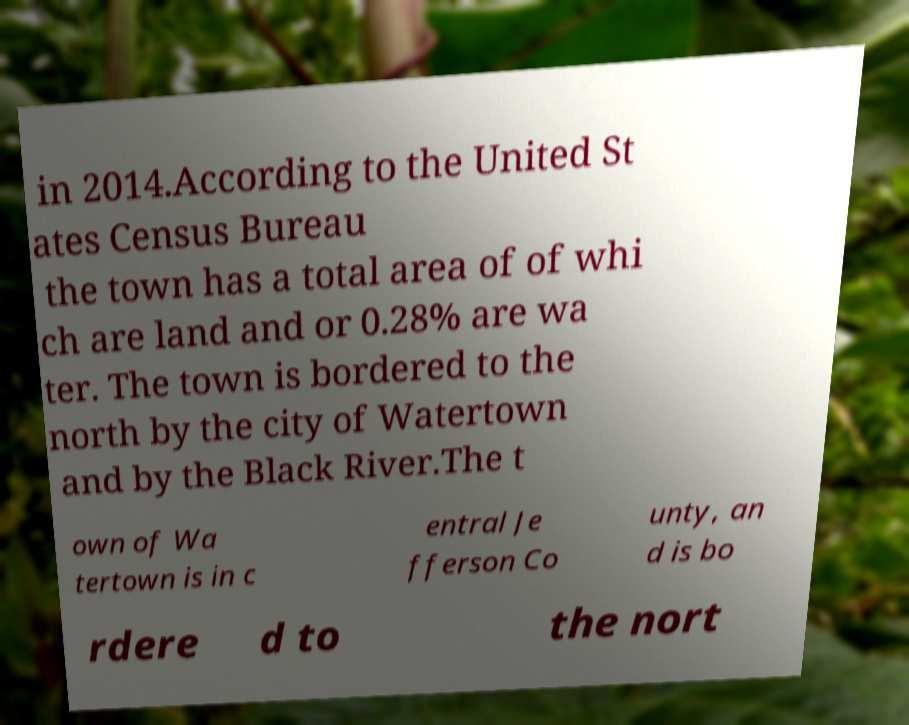Can you read and provide the text displayed in the image?This photo seems to have some interesting text. Can you extract and type it out for me? in 2014.According to the United St ates Census Bureau the town has a total area of of whi ch are land and or 0.28% are wa ter. The town is bordered to the north by the city of Watertown and by the Black River.The t own of Wa tertown is in c entral Je fferson Co unty, an d is bo rdere d to the nort 